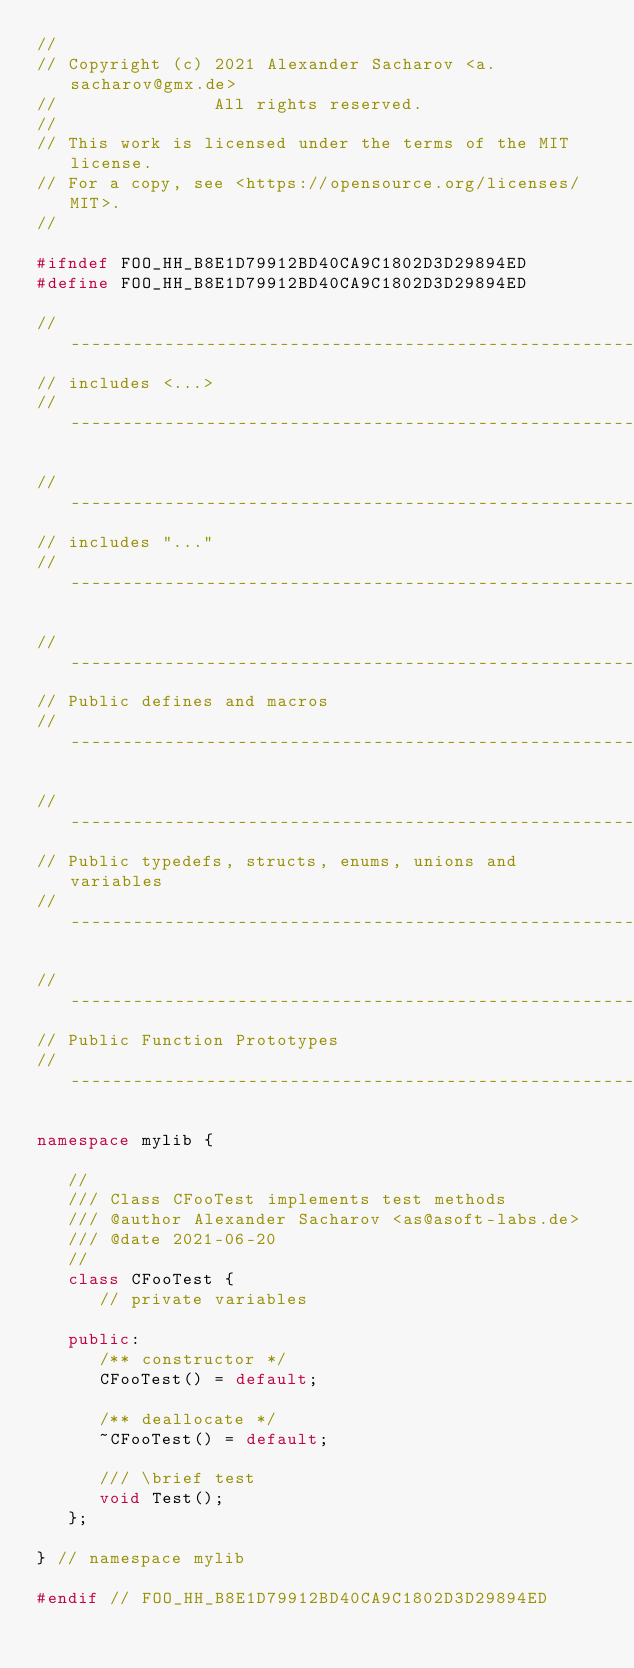Convert code to text. <code><loc_0><loc_0><loc_500><loc_500><_C++_>//
// Copyright (c) 2021 Alexander Sacharov <a.sacharov@gmx.de>
//               All rights reserved.
//
// This work is licensed under the terms of the MIT license.
// For a copy, see <https://opensource.org/licenses/MIT>.
//

#ifndef FOO_HH_B8E1D79912BD40CA9C1802D3D29894ED
#define FOO_HH_B8E1D79912BD40CA9C1802D3D29894ED

//-----------------------------------------------------------------------------
// includes <...>
//-----------------------------------------------------------------------------

//-----------------------------------------------------------------------------
// includes "..."
//-----------------------------------------------------------------------------

//----------------------------------------------------------------------------
// Public defines and macros
//----------------------------------------------------------------------------

//----------------------------------------------------------------------------
// Public typedefs, structs, enums, unions and variables
//----------------------------------------------------------------------------

//----------------------------------------------------------------------------
// Public Function Prototypes
//----------------------------------------------------------------------------

namespace mylib {

   //
   /// Class CFooTest implements test methods
   /// @author Alexander Sacharov <as@asoft-labs.de>
   /// @date 2021-06-20
   //
   class CFooTest {
      // private variables

   public:
      /** constructor */
      CFooTest() = default;

      /** deallocate */
      ~CFooTest() = default;

      /// \brief test
      void Test();
   };

} // namespace mylib

#endif // FOO_HH_B8E1D79912BD40CA9C1802D3D29894ED
</code> 